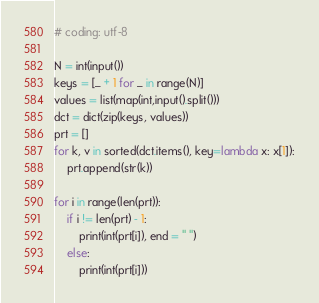<code> <loc_0><loc_0><loc_500><loc_500><_Python_># coding: utf-8

N = int(input())
keys = [_ + 1 for _ in range(N)]
values = list(map(int,input().split()))
dct = dict(zip(keys, values))
prt = []
for k, v in sorted(dct.items(), key=lambda x: x[1]):
    prt.append(str(k))

for i in range(len(prt)):
    if i != len(prt) - 1:
        print(int(prt[i]), end = " ")
    else:
        print(int(prt[i]))</code> 